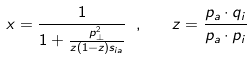Convert formula to latex. <formula><loc_0><loc_0><loc_500><loc_500>x = \frac { 1 } { 1 + \frac { p _ { \perp } ^ { 2 } } { z ( 1 - z ) s _ { i a } } } \ , \quad z = \frac { p _ { a } \cdot q _ { i } } { p _ { a } \cdot p _ { i } }</formula> 